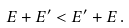<formula> <loc_0><loc_0><loc_500><loc_500>E + E ^ { \prime } < E ^ { \prime } + E \, .</formula> 